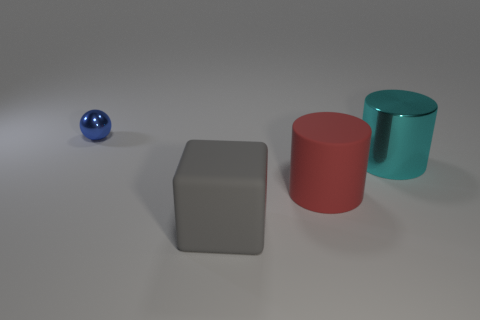Add 3 brown matte cylinders. How many objects exist? 7 Subtract all red cylinders. How many cylinders are left? 1 Subtract all blocks. How many objects are left? 3 Subtract 0 yellow blocks. How many objects are left? 4 Subtract 1 cylinders. How many cylinders are left? 1 Subtract all brown balls. Subtract all blue blocks. How many balls are left? 1 Subtract all blue cylinders. How many blue blocks are left? 0 Subtract all big yellow blocks. Subtract all big things. How many objects are left? 1 Add 3 tiny blue metallic balls. How many tiny blue metallic balls are left? 4 Add 2 large shiny cylinders. How many large shiny cylinders exist? 3 